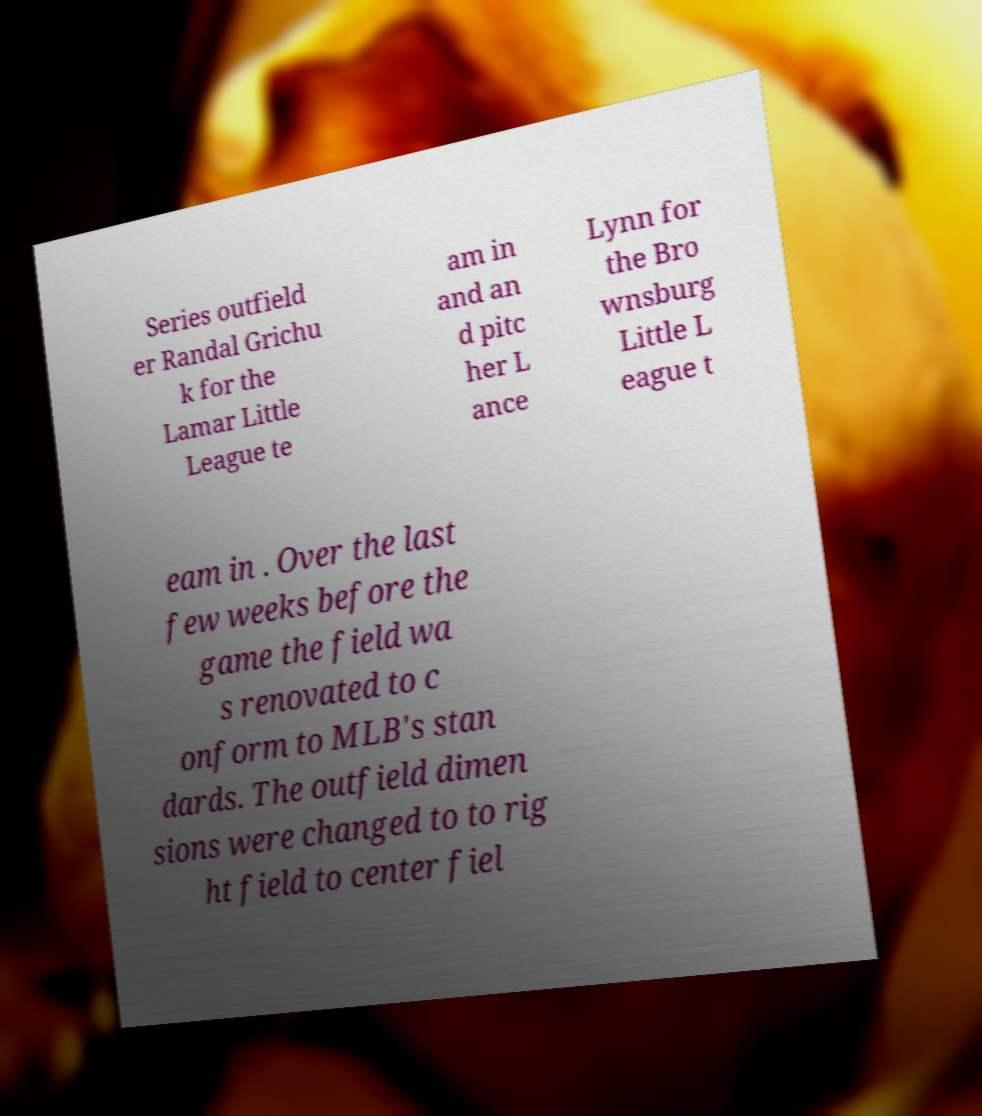Could you extract and type out the text from this image? Series outfield er Randal Grichu k for the Lamar Little League te am in and an d pitc her L ance Lynn for the Bro wnsburg Little L eague t eam in . Over the last few weeks before the game the field wa s renovated to c onform to MLB's stan dards. The outfield dimen sions were changed to to rig ht field to center fiel 